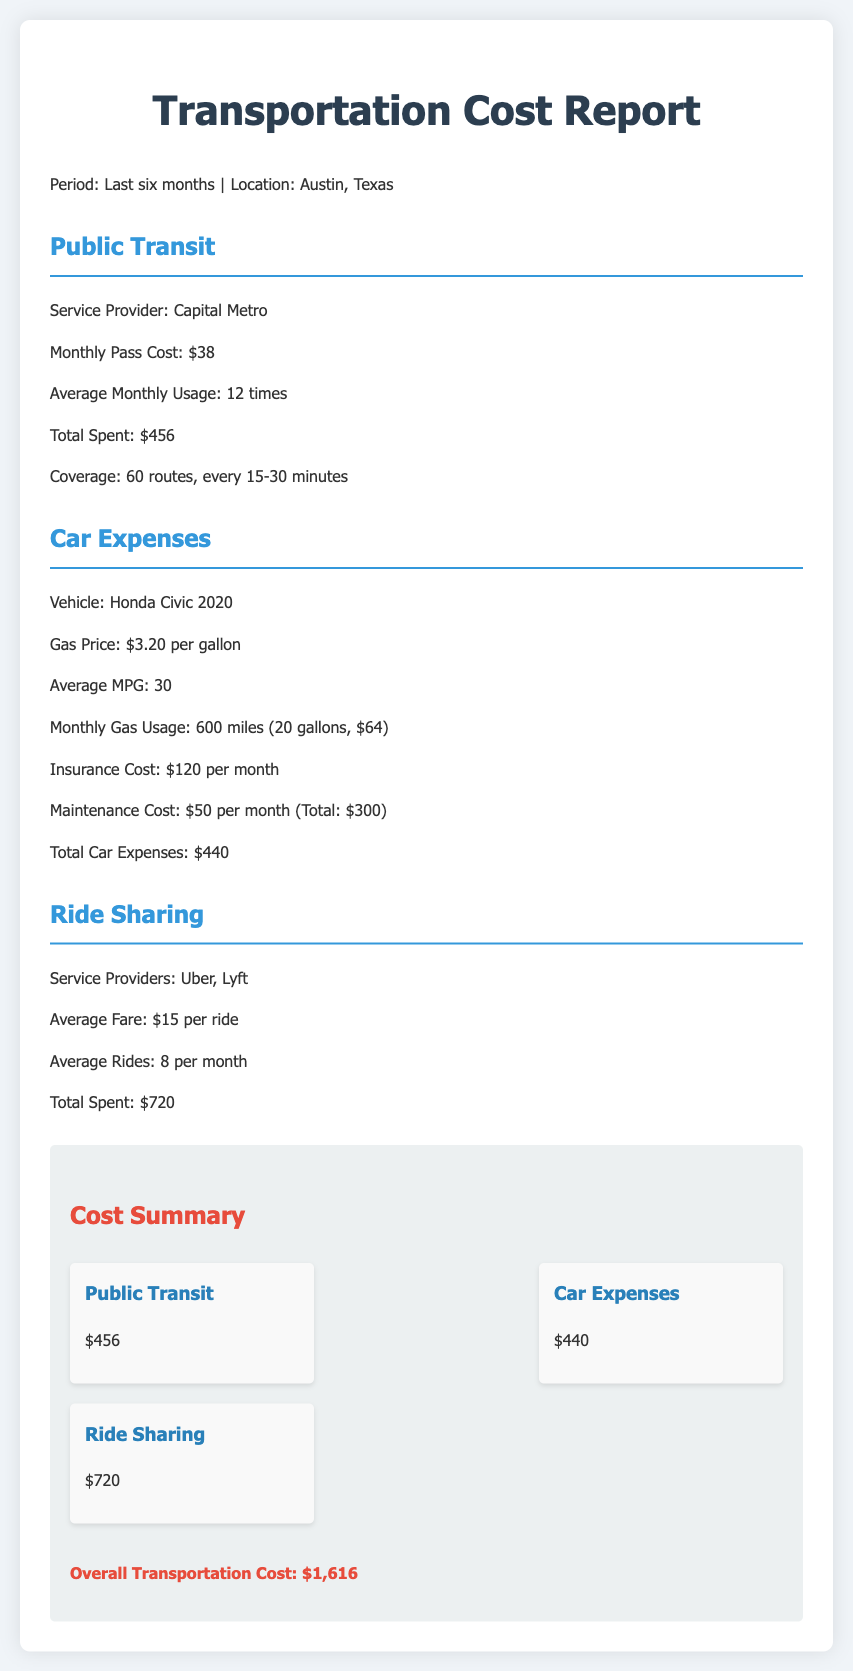what is the total spent on public transit? The total spent on public transit is mentioned in the document as $456.
Answer: $456 how much does the monthly pass for public transit cost? The document states that the monthly pass cost for public transit is $38.
Answer: $38 what is the average fare for ride sharing services? The document mentions that the average fare for ride sharing is $15 per ride.
Answer: $15 how many rides are taken on average per month for ride sharing? According to the document, the average rides taken are 8 per month.
Answer: 8 what is the total car expenses? The document lists the total car expenses as $440.
Answer: $440 what is the overall transportation cost? The overall transportation cost is provided in the summary as $1,616.
Answer: $1,616 how many routes does the public transit service cover? The document indicates that public transit covers 60 routes.
Answer: 60 how much is the monthly insurance cost for the car? The document specifies that the monthly insurance cost is $120.
Answer: $120 what vehicle is mentioned for car expenses? The document refers to a Honda Civic 2020 as the vehicle for car expenses.
Answer: Honda Civic 2020 